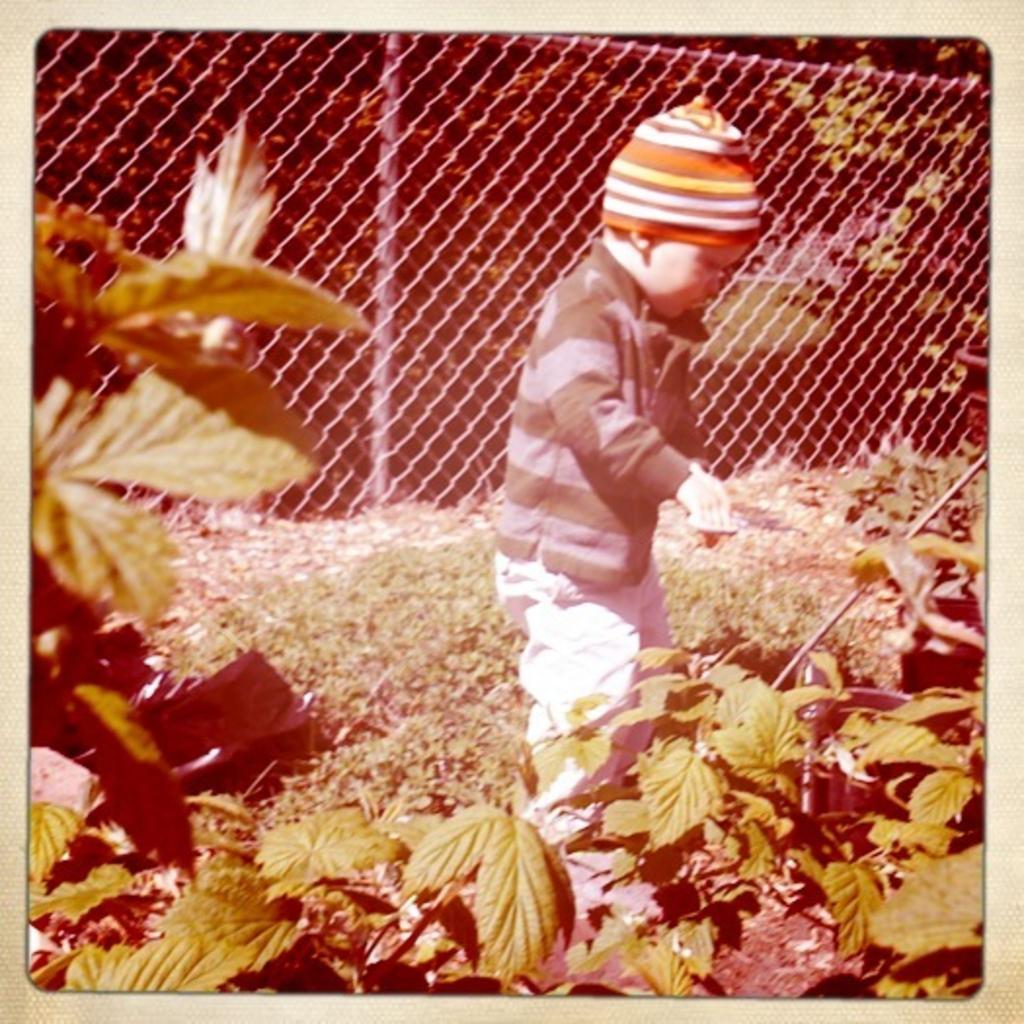In one or two sentences, can you explain what this image depicts? In this picture I can see a boy standing and I can see a boy standing and he wore a cap on his head and I can see plants and trees and I can see a metal fence and grass on the ground. 